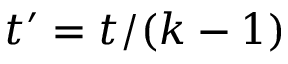Convert formula to latex. <formula><loc_0><loc_0><loc_500><loc_500>t ^ { \prime } = t / ( k - 1 )</formula> 